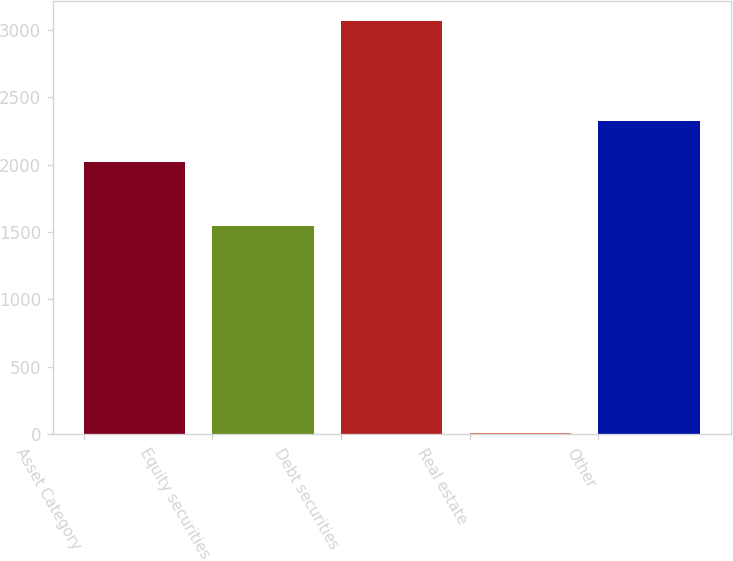<chart> <loc_0><loc_0><loc_500><loc_500><bar_chart><fcel>Asset Category<fcel>Equity securities<fcel>Debt securities<fcel>Real estate<fcel>Other<nl><fcel>2018<fcel>1545<fcel>3065<fcel>10<fcel>2323.5<nl></chart> 